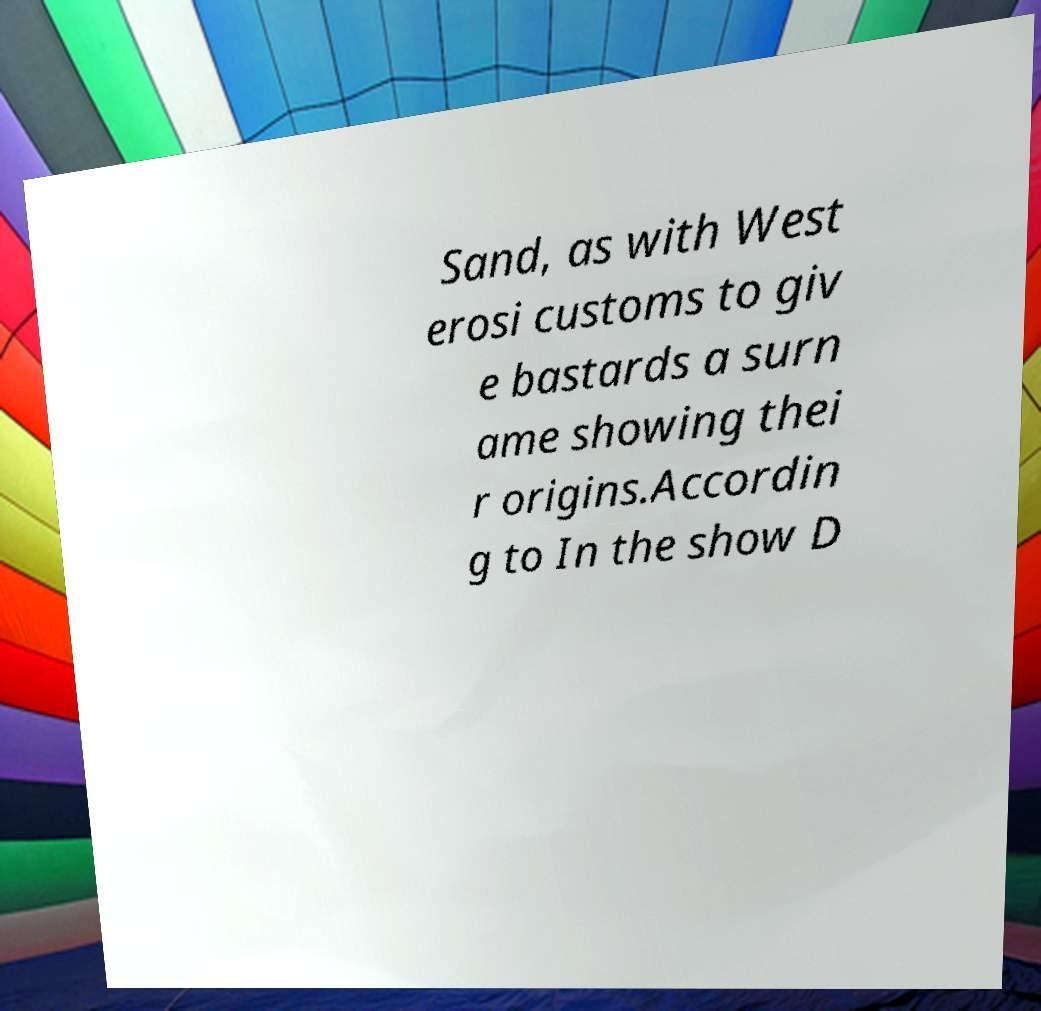What messages or text are displayed in this image? I need them in a readable, typed format. Sand, as with West erosi customs to giv e bastards a surn ame showing thei r origins.Accordin g to In the show D 